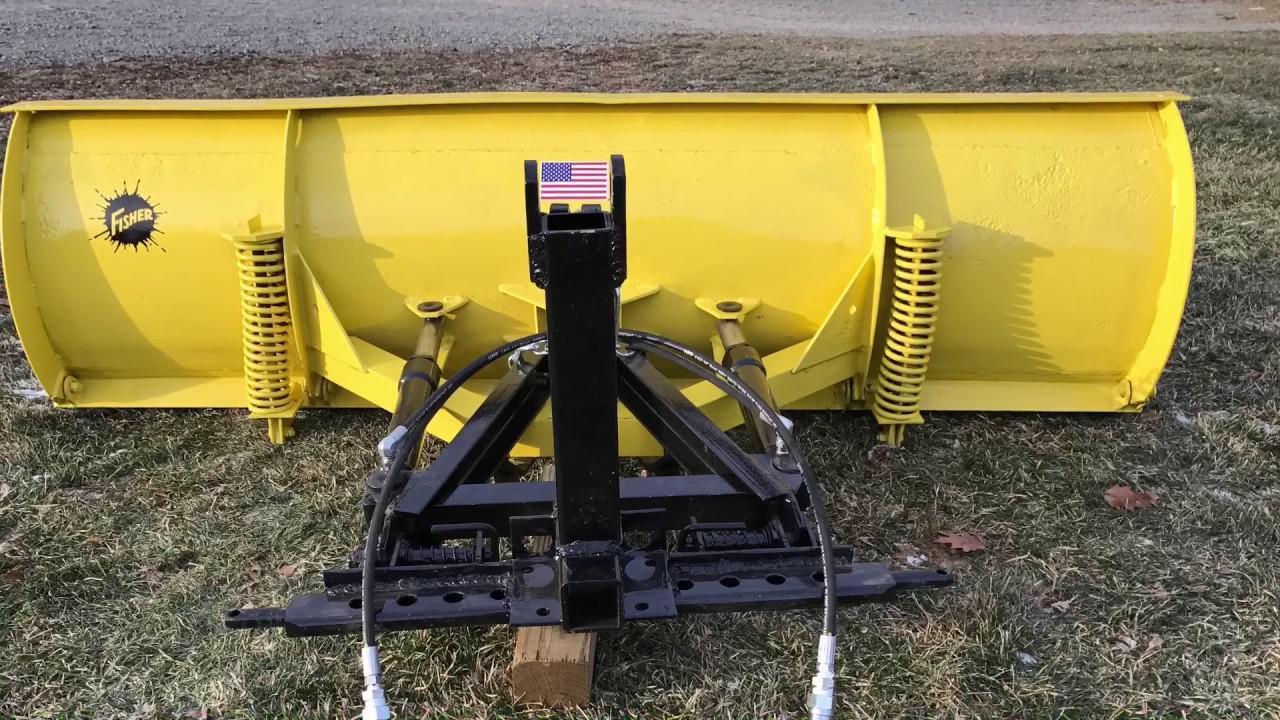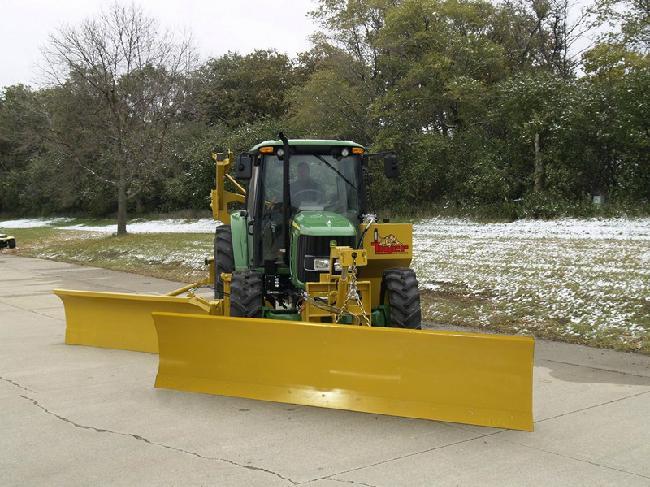The first image is the image on the left, the second image is the image on the right. Considering the images on both sides, is "A person is standing near a yellow heavy duty truck." valid? Answer yes or no. No. The first image is the image on the left, the second image is the image on the right. Given the left and right images, does the statement "In one image, on a snowy street, a yellow snow blade is attached to a dark truck with extra headlights." hold true? Answer yes or no. No. 